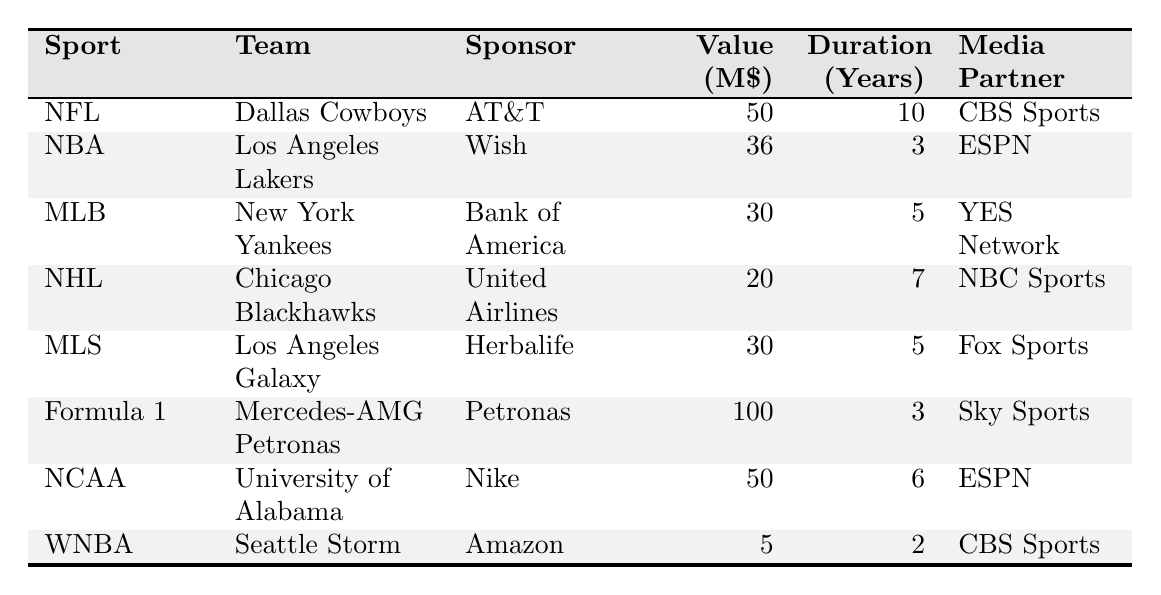What is the highest sponsorship deal value among the sports listed? The table shows deal values for each sport. Scanning through the values, I see that the highest value is 100 million for the Formula 1 team "Mercedes-AMG Petronas" sponsored by Petronas.
Answer: 100 million Which sport has the shortest sponsorship duration? Looking at the duration column, the shortest duration listed is 2 years for the WNBA team "Seattle Storm" sponsored by Amazon.
Answer: 2 years What is the total deal value for NCAA and WNBA combined? The deal value for NCAA (50 million) and WNBA (5 million) adds up to 50 + 5 = 55 million.
Answer: 55 million Is there a sponsorship deal with a value over 60 million? Checking the values listed, no deal exceeds 60 million. The highest is 100 million, but that's for Formula 1, and the other deals are all lower.
Answer: No What is the average deal value of all sponsorship deals listed? To find the average, I first sum all the deal values: (50 + 36 + 30 + 20 + 30 + 100 + 50 + 5) = 321. Then, I divide by the number of deals, which is 8. Therefore, the average deal value is 321 / 8 = 40.125 million.
Answer: 40.125 million Which team's deal has a media partnership with ESPN? Scanning the media partnership column, I see that both the NBA team "Los Angeles Lakers" and the NCAA team "University of Alabama" have media partnerships with ESPN.
Answer: Los Angeles Lakers, University of Alabama How many teams have sponsorship deals valued at 30 million or less? I check the deal values and find "Chicago Blackhawks" at 20 million and "Seattle Storm" at 5 million, making a total of 2 teams that have deals below or equal to 30 million.
Answer: 2 teams Which sport has the longest sponsorship duration, and what is that duration? Upon reviewing the duration column, the longest duration is 10 years for the NFL team "Dallas Cowboys" with AT&T.
Answer: NFL, 10 years 